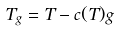Convert formula to latex. <formula><loc_0><loc_0><loc_500><loc_500>T _ { g } = T - c ( T ) g</formula> 